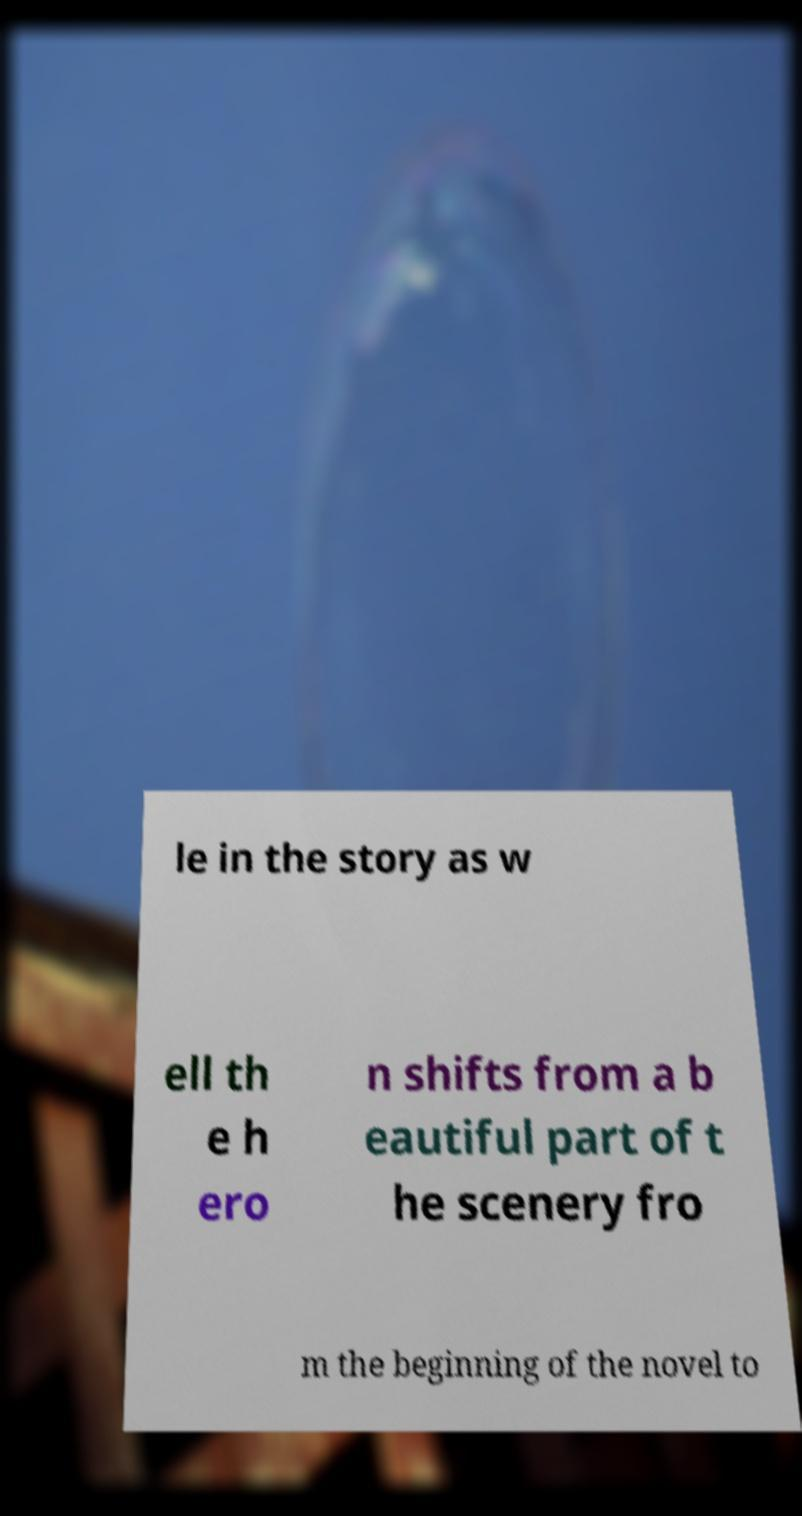I need the written content from this picture converted into text. Can you do that? le in the story as w ell th e h ero n shifts from a b eautiful part of t he scenery fro m the beginning of the novel to 